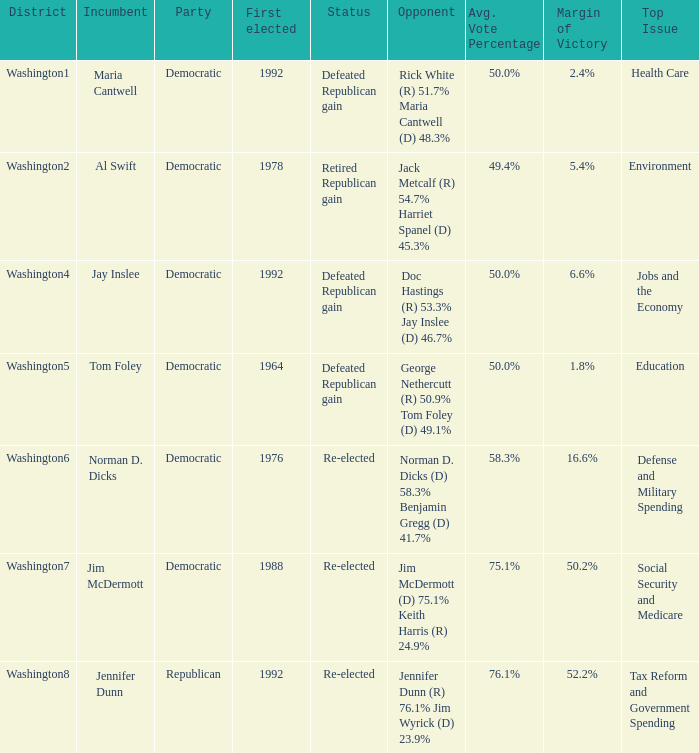What year was incumbent jim mcdermott first elected? 1988.0. 